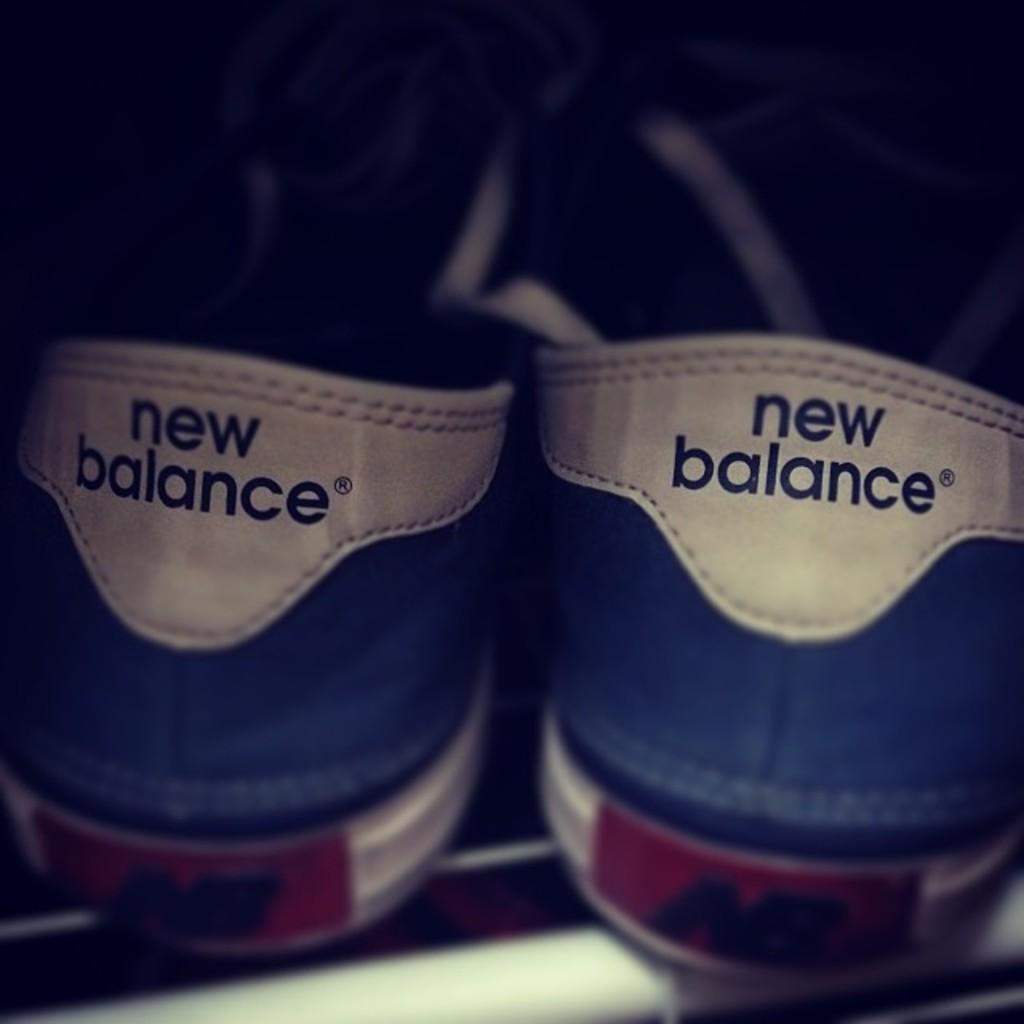What objects are in the middle of the image? There is a pair of shoes in the middle of the image. What can be seen on the shoes? There is text on the shoes. What type of coil is visible in the image? There is no coil present in the image. Can you describe the drain in the image? There is no drain present in the image. 